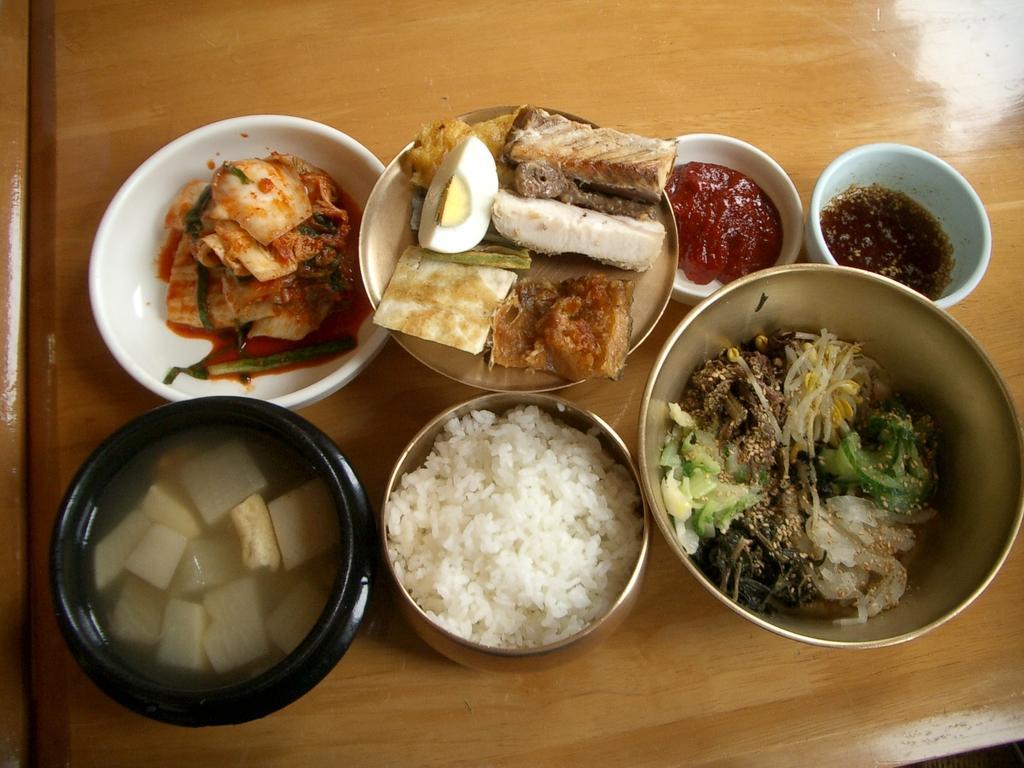Please provide a concise description of this image. In this image I can see there are many food items in different bowls on a dining table. 